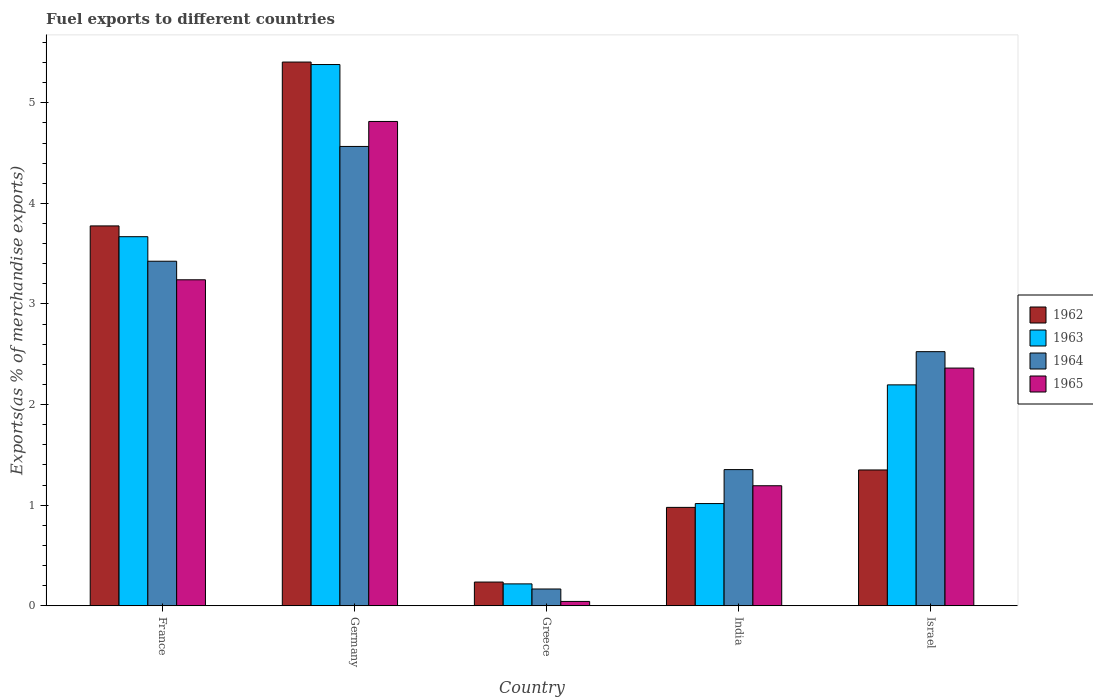How many different coloured bars are there?
Keep it short and to the point. 4. Are the number of bars on each tick of the X-axis equal?
Make the answer very short. Yes. How many bars are there on the 1st tick from the left?
Your response must be concise. 4. What is the label of the 2nd group of bars from the left?
Ensure brevity in your answer.  Germany. What is the percentage of exports to different countries in 1963 in France?
Keep it short and to the point. 3.67. Across all countries, what is the maximum percentage of exports to different countries in 1964?
Your answer should be very brief. 4.57. Across all countries, what is the minimum percentage of exports to different countries in 1965?
Provide a short and direct response. 0.04. In which country was the percentage of exports to different countries in 1964 minimum?
Keep it short and to the point. Greece. What is the total percentage of exports to different countries in 1963 in the graph?
Ensure brevity in your answer.  12.48. What is the difference between the percentage of exports to different countries in 1965 in France and that in India?
Offer a very short reply. 2.05. What is the difference between the percentage of exports to different countries in 1962 in India and the percentage of exports to different countries in 1963 in France?
Provide a short and direct response. -2.69. What is the average percentage of exports to different countries in 1962 per country?
Provide a succinct answer. 2.35. What is the difference between the percentage of exports to different countries of/in 1965 and percentage of exports to different countries of/in 1963 in Germany?
Make the answer very short. -0.57. What is the ratio of the percentage of exports to different countries in 1963 in France to that in Israel?
Ensure brevity in your answer.  1.67. What is the difference between the highest and the second highest percentage of exports to different countries in 1965?
Give a very brief answer. -0.88. What is the difference between the highest and the lowest percentage of exports to different countries in 1965?
Give a very brief answer. 4.77. Is it the case that in every country, the sum of the percentage of exports to different countries in 1964 and percentage of exports to different countries in 1962 is greater than the sum of percentage of exports to different countries in 1965 and percentage of exports to different countries in 1963?
Provide a short and direct response. No. What does the 2nd bar from the left in Germany represents?
Make the answer very short. 1963. What does the 2nd bar from the right in Germany represents?
Your response must be concise. 1964. How many countries are there in the graph?
Offer a terse response. 5. What is the difference between two consecutive major ticks on the Y-axis?
Your answer should be very brief. 1. Does the graph contain any zero values?
Keep it short and to the point. No. How many legend labels are there?
Your answer should be compact. 4. What is the title of the graph?
Offer a terse response. Fuel exports to different countries. What is the label or title of the Y-axis?
Ensure brevity in your answer.  Exports(as % of merchandise exports). What is the Exports(as % of merchandise exports) of 1962 in France?
Give a very brief answer. 3.78. What is the Exports(as % of merchandise exports) in 1963 in France?
Keep it short and to the point. 3.67. What is the Exports(as % of merchandise exports) in 1964 in France?
Offer a terse response. 3.43. What is the Exports(as % of merchandise exports) of 1965 in France?
Offer a very short reply. 3.24. What is the Exports(as % of merchandise exports) of 1962 in Germany?
Offer a very short reply. 5.4. What is the Exports(as % of merchandise exports) of 1963 in Germany?
Ensure brevity in your answer.  5.38. What is the Exports(as % of merchandise exports) of 1964 in Germany?
Keep it short and to the point. 4.57. What is the Exports(as % of merchandise exports) in 1965 in Germany?
Give a very brief answer. 4.81. What is the Exports(as % of merchandise exports) in 1962 in Greece?
Your answer should be compact. 0.24. What is the Exports(as % of merchandise exports) in 1963 in Greece?
Your answer should be very brief. 0.22. What is the Exports(as % of merchandise exports) of 1964 in Greece?
Give a very brief answer. 0.17. What is the Exports(as % of merchandise exports) of 1965 in Greece?
Offer a very short reply. 0.04. What is the Exports(as % of merchandise exports) in 1962 in India?
Make the answer very short. 0.98. What is the Exports(as % of merchandise exports) in 1963 in India?
Ensure brevity in your answer.  1.02. What is the Exports(as % of merchandise exports) in 1964 in India?
Your answer should be very brief. 1.35. What is the Exports(as % of merchandise exports) in 1965 in India?
Your answer should be very brief. 1.19. What is the Exports(as % of merchandise exports) of 1962 in Israel?
Offer a very short reply. 1.35. What is the Exports(as % of merchandise exports) in 1963 in Israel?
Your response must be concise. 2.2. What is the Exports(as % of merchandise exports) in 1964 in Israel?
Offer a terse response. 2.53. What is the Exports(as % of merchandise exports) of 1965 in Israel?
Make the answer very short. 2.36. Across all countries, what is the maximum Exports(as % of merchandise exports) of 1962?
Provide a short and direct response. 5.4. Across all countries, what is the maximum Exports(as % of merchandise exports) of 1963?
Provide a succinct answer. 5.38. Across all countries, what is the maximum Exports(as % of merchandise exports) in 1964?
Your response must be concise. 4.57. Across all countries, what is the maximum Exports(as % of merchandise exports) of 1965?
Ensure brevity in your answer.  4.81. Across all countries, what is the minimum Exports(as % of merchandise exports) of 1962?
Ensure brevity in your answer.  0.24. Across all countries, what is the minimum Exports(as % of merchandise exports) of 1963?
Provide a succinct answer. 0.22. Across all countries, what is the minimum Exports(as % of merchandise exports) in 1964?
Provide a succinct answer. 0.17. Across all countries, what is the minimum Exports(as % of merchandise exports) in 1965?
Offer a terse response. 0.04. What is the total Exports(as % of merchandise exports) of 1962 in the graph?
Your answer should be compact. 11.75. What is the total Exports(as % of merchandise exports) of 1963 in the graph?
Provide a succinct answer. 12.48. What is the total Exports(as % of merchandise exports) of 1964 in the graph?
Provide a short and direct response. 12.04. What is the total Exports(as % of merchandise exports) of 1965 in the graph?
Provide a succinct answer. 11.66. What is the difference between the Exports(as % of merchandise exports) in 1962 in France and that in Germany?
Your answer should be very brief. -1.63. What is the difference between the Exports(as % of merchandise exports) of 1963 in France and that in Germany?
Your answer should be very brief. -1.71. What is the difference between the Exports(as % of merchandise exports) of 1964 in France and that in Germany?
Provide a short and direct response. -1.14. What is the difference between the Exports(as % of merchandise exports) of 1965 in France and that in Germany?
Provide a succinct answer. -1.57. What is the difference between the Exports(as % of merchandise exports) of 1962 in France and that in Greece?
Offer a very short reply. 3.54. What is the difference between the Exports(as % of merchandise exports) in 1963 in France and that in Greece?
Your response must be concise. 3.45. What is the difference between the Exports(as % of merchandise exports) in 1964 in France and that in Greece?
Offer a terse response. 3.26. What is the difference between the Exports(as % of merchandise exports) of 1965 in France and that in Greece?
Offer a terse response. 3.2. What is the difference between the Exports(as % of merchandise exports) in 1962 in France and that in India?
Keep it short and to the point. 2.8. What is the difference between the Exports(as % of merchandise exports) of 1963 in France and that in India?
Provide a short and direct response. 2.65. What is the difference between the Exports(as % of merchandise exports) of 1964 in France and that in India?
Provide a succinct answer. 2.07. What is the difference between the Exports(as % of merchandise exports) of 1965 in France and that in India?
Ensure brevity in your answer.  2.05. What is the difference between the Exports(as % of merchandise exports) in 1962 in France and that in Israel?
Ensure brevity in your answer.  2.43. What is the difference between the Exports(as % of merchandise exports) in 1963 in France and that in Israel?
Your response must be concise. 1.47. What is the difference between the Exports(as % of merchandise exports) in 1964 in France and that in Israel?
Offer a terse response. 0.9. What is the difference between the Exports(as % of merchandise exports) of 1965 in France and that in Israel?
Provide a short and direct response. 0.88. What is the difference between the Exports(as % of merchandise exports) of 1962 in Germany and that in Greece?
Give a very brief answer. 5.17. What is the difference between the Exports(as % of merchandise exports) in 1963 in Germany and that in Greece?
Give a very brief answer. 5.16. What is the difference between the Exports(as % of merchandise exports) of 1964 in Germany and that in Greece?
Give a very brief answer. 4.4. What is the difference between the Exports(as % of merchandise exports) in 1965 in Germany and that in Greece?
Your answer should be compact. 4.77. What is the difference between the Exports(as % of merchandise exports) in 1962 in Germany and that in India?
Keep it short and to the point. 4.43. What is the difference between the Exports(as % of merchandise exports) in 1963 in Germany and that in India?
Provide a short and direct response. 4.36. What is the difference between the Exports(as % of merchandise exports) in 1964 in Germany and that in India?
Your answer should be very brief. 3.21. What is the difference between the Exports(as % of merchandise exports) in 1965 in Germany and that in India?
Provide a short and direct response. 3.62. What is the difference between the Exports(as % of merchandise exports) of 1962 in Germany and that in Israel?
Offer a very short reply. 4.05. What is the difference between the Exports(as % of merchandise exports) in 1963 in Germany and that in Israel?
Give a very brief answer. 3.18. What is the difference between the Exports(as % of merchandise exports) in 1964 in Germany and that in Israel?
Make the answer very short. 2.04. What is the difference between the Exports(as % of merchandise exports) of 1965 in Germany and that in Israel?
Your answer should be compact. 2.45. What is the difference between the Exports(as % of merchandise exports) of 1962 in Greece and that in India?
Offer a very short reply. -0.74. What is the difference between the Exports(as % of merchandise exports) in 1963 in Greece and that in India?
Give a very brief answer. -0.8. What is the difference between the Exports(as % of merchandise exports) in 1964 in Greece and that in India?
Your response must be concise. -1.19. What is the difference between the Exports(as % of merchandise exports) of 1965 in Greece and that in India?
Offer a terse response. -1.15. What is the difference between the Exports(as % of merchandise exports) of 1962 in Greece and that in Israel?
Ensure brevity in your answer.  -1.11. What is the difference between the Exports(as % of merchandise exports) in 1963 in Greece and that in Israel?
Your answer should be compact. -1.98. What is the difference between the Exports(as % of merchandise exports) of 1964 in Greece and that in Israel?
Keep it short and to the point. -2.36. What is the difference between the Exports(as % of merchandise exports) in 1965 in Greece and that in Israel?
Your response must be concise. -2.32. What is the difference between the Exports(as % of merchandise exports) in 1962 in India and that in Israel?
Keep it short and to the point. -0.37. What is the difference between the Exports(as % of merchandise exports) in 1963 in India and that in Israel?
Your answer should be compact. -1.18. What is the difference between the Exports(as % of merchandise exports) of 1964 in India and that in Israel?
Make the answer very short. -1.17. What is the difference between the Exports(as % of merchandise exports) of 1965 in India and that in Israel?
Provide a short and direct response. -1.17. What is the difference between the Exports(as % of merchandise exports) in 1962 in France and the Exports(as % of merchandise exports) in 1963 in Germany?
Your answer should be compact. -1.6. What is the difference between the Exports(as % of merchandise exports) in 1962 in France and the Exports(as % of merchandise exports) in 1964 in Germany?
Ensure brevity in your answer.  -0.79. What is the difference between the Exports(as % of merchandise exports) in 1962 in France and the Exports(as % of merchandise exports) in 1965 in Germany?
Keep it short and to the point. -1.04. What is the difference between the Exports(as % of merchandise exports) in 1963 in France and the Exports(as % of merchandise exports) in 1964 in Germany?
Offer a terse response. -0.9. What is the difference between the Exports(as % of merchandise exports) of 1963 in France and the Exports(as % of merchandise exports) of 1965 in Germany?
Ensure brevity in your answer.  -1.15. What is the difference between the Exports(as % of merchandise exports) of 1964 in France and the Exports(as % of merchandise exports) of 1965 in Germany?
Your answer should be very brief. -1.39. What is the difference between the Exports(as % of merchandise exports) in 1962 in France and the Exports(as % of merchandise exports) in 1963 in Greece?
Your answer should be compact. 3.56. What is the difference between the Exports(as % of merchandise exports) in 1962 in France and the Exports(as % of merchandise exports) in 1964 in Greece?
Your answer should be compact. 3.61. What is the difference between the Exports(as % of merchandise exports) of 1962 in France and the Exports(as % of merchandise exports) of 1965 in Greece?
Your answer should be very brief. 3.73. What is the difference between the Exports(as % of merchandise exports) of 1963 in France and the Exports(as % of merchandise exports) of 1964 in Greece?
Your answer should be compact. 3.5. What is the difference between the Exports(as % of merchandise exports) in 1963 in France and the Exports(as % of merchandise exports) in 1965 in Greece?
Offer a very short reply. 3.63. What is the difference between the Exports(as % of merchandise exports) of 1964 in France and the Exports(as % of merchandise exports) of 1965 in Greece?
Provide a succinct answer. 3.38. What is the difference between the Exports(as % of merchandise exports) of 1962 in France and the Exports(as % of merchandise exports) of 1963 in India?
Your response must be concise. 2.76. What is the difference between the Exports(as % of merchandise exports) in 1962 in France and the Exports(as % of merchandise exports) in 1964 in India?
Your answer should be very brief. 2.42. What is the difference between the Exports(as % of merchandise exports) in 1962 in France and the Exports(as % of merchandise exports) in 1965 in India?
Offer a terse response. 2.58. What is the difference between the Exports(as % of merchandise exports) in 1963 in France and the Exports(as % of merchandise exports) in 1964 in India?
Your answer should be very brief. 2.32. What is the difference between the Exports(as % of merchandise exports) of 1963 in France and the Exports(as % of merchandise exports) of 1965 in India?
Your answer should be compact. 2.48. What is the difference between the Exports(as % of merchandise exports) in 1964 in France and the Exports(as % of merchandise exports) in 1965 in India?
Your response must be concise. 2.23. What is the difference between the Exports(as % of merchandise exports) in 1962 in France and the Exports(as % of merchandise exports) in 1963 in Israel?
Provide a short and direct response. 1.58. What is the difference between the Exports(as % of merchandise exports) of 1962 in France and the Exports(as % of merchandise exports) of 1964 in Israel?
Give a very brief answer. 1.25. What is the difference between the Exports(as % of merchandise exports) in 1962 in France and the Exports(as % of merchandise exports) in 1965 in Israel?
Your answer should be very brief. 1.41. What is the difference between the Exports(as % of merchandise exports) of 1963 in France and the Exports(as % of merchandise exports) of 1964 in Israel?
Provide a short and direct response. 1.14. What is the difference between the Exports(as % of merchandise exports) of 1963 in France and the Exports(as % of merchandise exports) of 1965 in Israel?
Provide a short and direct response. 1.31. What is the difference between the Exports(as % of merchandise exports) in 1964 in France and the Exports(as % of merchandise exports) in 1965 in Israel?
Make the answer very short. 1.06. What is the difference between the Exports(as % of merchandise exports) in 1962 in Germany and the Exports(as % of merchandise exports) in 1963 in Greece?
Your answer should be compact. 5.19. What is the difference between the Exports(as % of merchandise exports) in 1962 in Germany and the Exports(as % of merchandise exports) in 1964 in Greece?
Ensure brevity in your answer.  5.24. What is the difference between the Exports(as % of merchandise exports) of 1962 in Germany and the Exports(as % of merchandise exports) of 1965 in Greece?
Your response must be concise. 5.36. What is the difference between the Exports(as % of merchandise exports) of 1963 in Germany and the Exports(as % of merchandise exports) of 1964 in Greece?
Ensure brevity in your answer.  5.21. What is the difference between the Exports(as % of merchandise exports) of 1963 in Germany and the Exports(as % of merchandise exports) of 1965 in Greece?
Your answer should be very brief. 5.34. What is the difference between the Exports(as % of merchandise exports) in 1964 in Germany and the Exports(as % of merchandise exports) in 1965 in Greece?
Ensure brevity in your answer.  4.52. What is the difference between the Exports(as % of merchandise exports) of 1962 in Germany and the Exports(as % of merchandise exports) of 1963 in India?
Offer a very short reply. 4.39. What is the difference between the Exports(as % of merchandise exports) in 1962 in Germany and the Exports(as % of merchandise exports) in 1964 in India?
Provide a succinct answer. 4.05. What is the difference between the Exports(as % of merchandise exports) in 1962 in Germany and the Exports(as % of merchandise exports) in 1965 in India?
Give a very brief answer. 4.21. What is the difference between the Exports(as % of merchandise exports) of 1963 in Germany and the Exports(as % of merchandise exports) of 1964 in India?
Give a very brief answer. 4.03. What is the difference between the Exports(as % of merchandise exports) in 1963 in Germany and the Exports(as % of merchandise exports) in 1965 in India?
Provide a succinct answer. 4.19. What is the difference between the Exports(as % of merchandise exports) in 1964 in Germany and the Exports(as % of merchandise exports) in 1965 in India?
Keep it short and to the point. 3.37. What is the difference between the Exports(as % of merchandise exports) of 1962 in Germany and the Exports(as % of merchandise exports) of 1963 in Israel?
Provide a short and direct response. 3.21. What is the difference between the Exports(as % of merchandise exports) of 1962 in Germany and the Exports(as % of merchandise exports) of 1964 in Israel?
Your response must be concise. 2.88. What is the difference between the Exports(as % of merchandise exports) in 1962 in Germany and the Exports(as % of merchandise exports) in 1965 in Israel?
Keep it short and to the point. 3.04. What is the difference between the Exports(as % of merchandise exports) of 1963 in Germany and the Exports(as % of merchandise exports) of 1964 in Israel?
Your response must be concise. 2.85. What is the difference between the Exports(as % of merchandise exports) of 1963 in Germany and the Exports(as % of merchandise exports) of 1965 in Israel?
Your answer should be very brief. 3.02. What is the difference between the Exports(as % of merchandise exports) of 1964 in Germany and the Exports(as % of merchandise exports) of 1965 in Israel?
Your answer should be compact. 2.2. What is the difference between the Exports(as % of merchandise exports) of 1962 in Greece and the Exports(as % of merchandise exports) of 1963 in India?
Give a very brief answer. -0.78. What is the difference between the Exports(as % of merchandise exports) of 1962 in Greece and the Exports(as % of merchandise exports) of 1964 in India?
Your answer should be compact. -1.12. What is the difference between the Exports(as % of merchandise exports) in 1962 in Greece and the Exports(as % of merchandise exports) in 1965 in India?
Make the answer very short. -0.96. What is the difference between the Exports(as % of merchandise exports) of 1963 in Greece and the Exports(as % of merchandise exports) of 1964 in India?
Provide a short and direct response. -1.14. What is the difference between the Exports(as % of merchandise exports) of 1963 in Greece and the Exports(as % of merchandise exports) of 1965 in India?
Make the answer very short. -0.98. What is the difference between the Exports(as % of merchandise exports) of 1964 in Greece and the Exports(as % of merchandise exports) of 1965 in India?
Your response must be concise. -1.03. What is the difference between the Exports(as % of merchandise exports) of 1962 in Greece and the Exports(as % of merchandise exports) of 1963 in Israel?
Offer a terse response. -1.96. What is the difference between the Exports(as % of merchandise exports) in 1962 in Greece and the Exports(as % of merchandise exports) in 1964 in Israel?
Provide a succinct answer. -2.29. What is the difference between the Exports(as % of merchandise exports) of 1962 in Greece and the Exports(as % of merchandise exports) of 1965 in Israel?
Your answer should be very brief. -2.13. What is the difference between the Exports(as % of merchandise exports) in 1963 in Greece and the Exports(as % of merchandise exports) in 1964 in Israel?
Provide a succinct answer. -2.31. What is the difference between the Exports(as % of merchandise exports) of 1963 in Greece and the Exports(as % of merchandise exports) of 1965 in Israel?
Offer a very short reply. -2.15. What is the difference between the Exports(as % of merchandise exports) in 1964 in Greece and the Exports(as % of merchandise exports) in 1965 in Israel?
Provide a succinct answer. -2.2. What is the difference between the Exports(as % of merchandise exports) in 1962 in India and the Exports(as % of merchandise exports) in 1963 in Israel?
Offer a very short reply. -1.22. What is the difference between the Exports(as % of merchandise exports) in 1962 in India and the Exports(as % of merchandise exports) in 1964 in Israel?
Ensure brevity in your answer.  -1.55. What is the difference between the Exports(as % of merchandise exports) of 1962 in India and the Exports(as % of merchandise exports) of 1965 in Israel?
Offer a very short reply. -1.38. What is the difference between the Exports(as % of merchandise exports) in 1963 in India and the Exports(as % of merchandise exports) in 1964 in Israel?
Your response must be concise. -1.51. What is the difference between the Exports(as % of merchandise exports) of 1963 in India and the Exports(as % of merchandise exports) of 1965 in Israel?
Your answer should be very brief. -1.35. What is the difference between the Exports(as % of merchandise exports) of 1964 in India and the Exports(as % of merchandise exports) of 1965 in Israel?
Provide a short and direct response. -1.01. What is the average Exports(as % of merchandise exports) of 1962 per country?
Provide a short and direct response. 2.35. What is the average Exports(as % of merchandise exports) of 1963 per country?
Make the answer very short. 2.5. What is the average Exports(as % of merchandise exports) of 1964 per country?
Keep it short and to the point. 2.41. What is the average Exports(as % of merchandise exports) of 1965 per country?
Give a very brief answer. 2.33. What is the difference between the Exports(as % of merchandise exports) of 1962 and Exports(as % of merchandise exports) of 1963 in France?
Keep it short and to the point. 0.11. What is the difference between the Exports(as % of merchandise exports) of 1962 and Exports(as % of merchandise exports) of 1964 in France?
Make the answer very short. 0.35. What is the difference between the Exports(as % of merchandise exports) in 1962 and Exports(as % of merchandise exports) in 1965 in France?
Your response must be concise. 0.54. What is the difference between the Exports(as % of merchandise exports) of 1963 and Exports(as % of merchandise exports) of 1964 in France?
Offer a very short reply. 0.24. What is the difference between the Exports(as % of merchandise exports) of 1963 and Exports(as % of merchandise exports) of 1965 in France?
Keep it short and to the point. 0.43. What is the difference between the Exports(as % of merchandise exports) of 1964 and Exports(as % of merchandise exports) of 1965 in France?
Give a very brief answer. 0.18. What is the difference between the Exports(as % of merchandise exports) in 1962 and Exports(as % of merchandise exports) in 1963 in Germany?
Your response must be concise. 0.02. What is the difference between the Exports(as % of merchandise exports) in 1962 and Exports(as % of merchandise exports) in 1964 in Germany?
Keep it short and to the point. 0.84. What is the difference between the Exports(as % of merchandise exports) of 1962 and Exports(as % of merchandise exports) of 1965 in Germany?
Your response must be concise. 0.59. What is the difference between the Exports(as % of merchandise exports) in 1963 and Exports(as % of merchandise exports) in 1964 in Germany?
Your response must be concise. 0.81. What is the difference between the Exports(as % of merchandise exports) of 1963 and Exports(as % of merchandise exports) of 1965 in Germany?
Offer a very short reply. 0.57. What is the difference between the Exports(as % of merchandise exports) in 1964 and Exports(as % of merchandise exports) in 1965 in Germany?
Keep it short and to the point. -0.25. What is the difference between the Exports(as % of merchandise exports) of 1962 and Exports(as % of merchandise exports) of 1963 in Greece?
Provide a succinct answer. 0.02. What is the difference between the Exports(as % of merchandise exports) of 1962 and Exports(as % of merchandise exports) of 1964 in Greece?
Give a very brief answer. 0.07. What is the difference between the Exports(as % of merchandise exports) of 1962 and Exports(as % of merchandise exports) of 1965 in Greece?
Ensure brevity in your answer.  0.19. What is the difference between the Exports(as % of merchandise exports) of 1963 and Exports(as % of merchandise exports) of 1964 in Greece?
Keep it short and to the point. 0.05. What is the difference between the Exports(as % of merchandise exports) of 1963 and Exports(as % of merchandise exports) of 1965 in Greece?
Offer a terse response. 0.17. What is the difference between the Exports(as % of merchandise exports) in 1964 and Exports(as % of merchandise exports) in 1965 in Greece?
Provide a short and direct response. 0.12. What is the difference between the Exports(as % of merchandise exports) in 1962 and Exports(as % of merchandise exports) in 1963 in India?
Give a very brief answer. -0.04. What is the difference between the Exports(as % of merchandise exports) in 1962 and Exports(as % of merchandise exports) in 1964 in India?
Offer a terse response. -0.38. What is the difference between the Exports(as % of merchandise exports) of 1962 and Exports(as % of merchandise exports) of 1965 in India?
Offer a terse response. -0.22. What is the difference between the Exports(as % of merchandise exports) in 1963 and Exports(as % of merchandise exports) in 1964 in India?
Your answer should be very brief. -0.34. What is the difference between the Exports(as % of merchandise exports) of 1963 and Exports(as % of merchandise exports) of 1965 in India?
Your answer should be compact. -0.18. What is the difference between the Exports(as % of merchandise exports) in 1964 and Exports(as % of merchandise exports) in 1965 in India?
Provide a succinct answer. 0.16. What is the difference between the Exports(as % of merchandise exports) in 1962 and Exports(as % of merchandise exports) in 1963 in Israel?
Your response must be concise. -0.85. What is the difference between the Exports(as % of merchandise exports) of 1962 and Exports(as % of merchandise exports) of 1964 in Israel?
Provide a short and direct response. -1.18. What is the difference between the Exports(as % of merchandise exports) of 1962 and Exports(as % of merchandise exports) of 1965 in Israel?
Your response must be concise. -1.01. What is the difference between the Exports(as % of merchandise exports) in 1963 and Exports(as % of merchandise exports) in 1964 in Israel?
Your answer should be compact. -0.33. What is the difference between the Exports(as % of merchandise exports) of 1963 and Exports(as % of merchandise exports) of 1965 in Israel?
Your answer should be very brief. -0.17. What is the difference between the Exports(as % of merchandise exports) in 1964 and Exports(as % of merchandise exports) in 1965 in Israel?
Offer a terse response. 0.16. What is the ratio of the Exports(as % of merchandise exports) in 1962 in France to that in Germany?
Offer a very short reply. 0.7. What is the ratio of the Exports(as % of merchandise exports) in 1963 in France to that in Germany?
Ensure brevity in your answer.  0.68. What is the ratio of the Exports(as % of merchandise exports) in 1964 in France to that in Germany?
Your answer should be compact. 0.75. What is the ratio of the Exports(as % of merchandise exports) in 1965 in France to that in Germany?
Make the answer very short. 0.67. What is the ratio of the Exports(as % of merchandise exports) in 1962 in France to that in Greece?
Ensure brevity in your answer.  16.01. What is the ratio of the Exports(as % of merchandise exports) of 1963 in France to that in Greece?
Make the answer very short. 16.85. What is the ratio of the Exports(as % of merchandise exports) of 1964 in France to that in Greece?
Give a very brief answer. 20.5. What is the ratio of the Exports(as % of merchandise exports) in 1965 in France to that in Greece?
Provide a succinct answer. 74.69. What is the ratio of the Exports(as % of merchandise exports) in 1962 in France to that in India?
Offer a very short reply. 3.86. What is the ratio of the Exports(as % of merchandise exports) in 1963 in France to that in India?
Provide a succinct answer. 3.61. What is the ratio of the Exports(as % of merchandise exports) in 1964 in France to that in India?
Your answer should be compact. 2.53. What is the ratio of the Exports(as % of merchandise exports) in 1965 in France to that in India?
Make the answer very short. 2.72. What is the ratio of the Exports(as % of merchandise exports) of 1962 in France to that in Israel?
Your response must be concise. 2.8. What is the ratio of the Exports(as % of merchandise exports) of 1963 in France to that in Israel?
Provide a short and direct response. 1.67. What is the ratio of the Exports(as % of merchandise exports) of 1964 in France to that in Israel?
Ensure brevity in your answer.  1.36. What is the ratio of the Exports(as % of merchandise exports) in 1965 in France to that in Israel?
Provide a short and direct response. 1.37. What is the ratio of the Exports(as % of merchandise exports) in 1962 in Germany to that in Greece?
Your answer should be compact. 22.91. What is the ratio of the Exports(as % of merchandise exports) in 1963 in Germany to that in Greece?
Make the answer very short. 24.71. What is the ratio of the Exports(as % of merchandise exports) of 1964 in Germany to that in Greece?
Give a very brief answer. 27.34. What is the ratio of the Exports(as % of merchandise exports) in 1965 in Germany to that in Greece?
Give a very brief answer. 110.96. What is the ratio of the Exports(as % of merchandise exports) of 1962 in Germany to that in India?
Provide a short and direct response. 5.53. What is the ratio of the Exports(as % of merchandise exports) in 1963 in Germany to that in India?
Ensure brevity in your answer.  5.3. What is the ratio of the Exports(as % of merchandise exports) of 1964 in Germany to that in India?
Make the answer very short. 3.37. What is the ratio of the Exports(as % of merchandise exports) of 1965 in Germany to that in India?
Ensure brevity in your answer.  4.03. What is the ratio of the Exports(as % of merchandise exports) of 1962 in Germany to that in Israel?
Your response must be concise. 4. What is the ratio of the Exports(as % of merchandise exports) of 1963 in Germany to that in Israel?
Your response must be concise. 2.45. What is the ratio of the Exports(as % of merchandise exports) of 1964 in Germany to that in Israel?
Offer a terse response. 1.81. What is the ratio of the Exports(as % of merchandise exports) in 1965 in Germany to that in Israel?
Offer a terse response. 2.04. What is the ratio of the Exports(as % of merchandise exports) in 1962 in Greece to that in India?
Your answer should be compact. 0.24. What is the ratio of the Exports(as % of merchandise exports) in 1963 in Greece to that in India?
Ensure brevity in your answer.  0.21. What is the ratio of the Exports(as % of merchandise exports) in 1964 in Greece to that in India?
Your response must be concise. 0.12. What is the ratio of the Exports(as % of merchandise exports) of 1965 in Greece to that in India?
Provide a short and direct response. 0.04. What is the ratio of the Exports(as % of merchandise exports) of 1962 in Greece to that in Israel?
Your response must be concise. 0.17. What is the ratio of the Exports(as % of merchandise exports) in 1963 in Greece to that in Israel?
Your answer should be very brief. 0.1. What is the ratio of the Exports(as % of merchandise exports) of 1964 in Greece to that in Israel?
Your response must be concise. 0.07. What is the ratio of the Exports(as % of merchandise exports) of 1965 in Greece to that in Israel?
Make the answer very short. 0.02. What is the ratio of the Exports(as % of merchandise exports) of 1962 in India to that in Israel?
Keep it short and to the point. 0.72. What is the ratio of the Exports(as % of merchandise exports) of 1963 in India to that in Israel?
Offer a terse response. 0.46. What is the ratio of the Exports(as % of merchandise exports) in 1964 in India to that in Israel?
Offer a very short reply. 0.54. What is the ratio of the Exports(as % of merchandise exports) of 1965 in India to that in Israel?
Keep it short and to the point. 0.51. What is the difference between the highest and the second highest Exports(as % of merchandise exports) of 1962?
Provide a short and direct response. 1.63. What is the difference between the highest and the second highest Exports(as % of merchandise exports) of 1963?
Your response must be concise. 1.71. What is the difference between the highest and the second highest Exports(as % of merchandise exports) in 1964?
Give a very brief answer. 1.14. What is the difference between the highest and the second highest Exports(as % of merchandise exports) in 1965?
Make the answer very short. 1.57. What is the difference between the highest and the lowest Exports(as % of merchandise exports) of 1962?
Provide a succinct answer. 5.17. What is the difference between the highest and the lowest Exports(as % of merchandise exports) of 1963?
Keep it short and to the point. 5.16. What is the difference between the highest and the lowest Exports(as % of merchandise exports) in 1964?
Your answer should be very brief. 4.4. What is the difference between the highest and the lowest Exports(as % of merchandise exports) in 1965?
Keep it short and to the point. 4.77. 